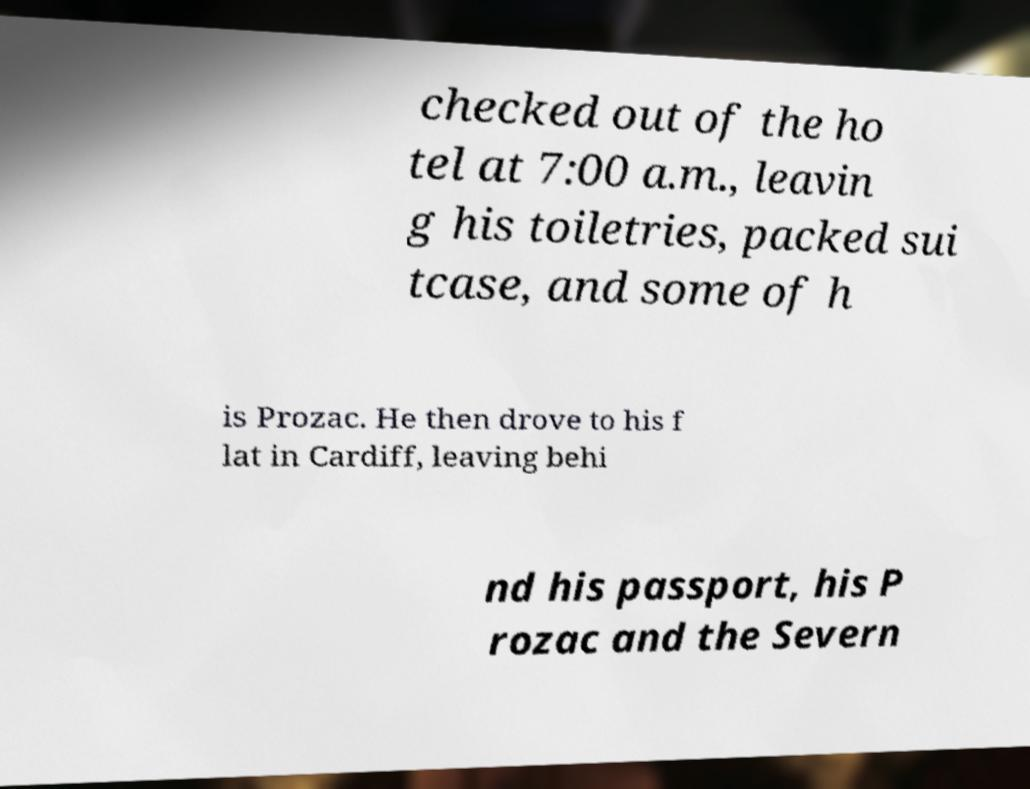For documentation purposes, I need the text within this image transcribed. Could you provide that? checked out of the ho tel at 7:00 a.m., leavin g his toiletries, packed sui tcase, and some of h is Prozac. He then drove to his f lat in Cardiff, leaving behi nd his passport, his P rozac and the Severn 